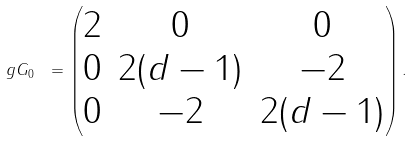<formula> <loc_0><loc_0><loc_500><loc_500>\ g G _ { 0 } \ = \begin{pmatrix} 2 & 0 & 0 \\ 0 & 2 ( d - 1 ) & - 2 \\ 0 & - 2 & 2 ( d - 1 ) \end{pmatrix} .</formula> 